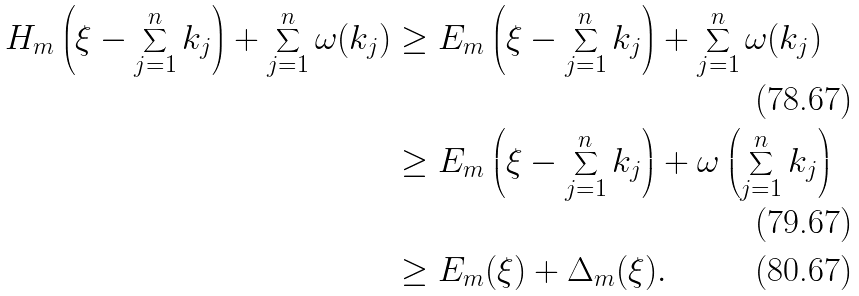Convert formula to latex. <formula><loc_0><loc_0><loc_500><loc_500>H _ { m } \left ( \xi - \sum _ { j = 1 } ^ { n } k _ { j } \right ) + \sum _ { j = 1 } ^ { n } \omega ( k _ { j } ) & \geq E _ { m } \left ( \xi - \sum _ { j = 1 } ^ { n } k _ { j } \right ) + \sum _ { j = 1 } ^ { n } \omega ( k _ { j } ) \\ & \geq E _ { m } \left ( \xi - \sum _ { j = 1 } ^ { n } k _ { j } \right ) + \omega \left ( \sum _ { j = 1 } ^ { n } k _ { j } \right ) \\ & \geq E _ { m } ( \xi ) + \Delta _ { m } ( \xi ) .</formula> 